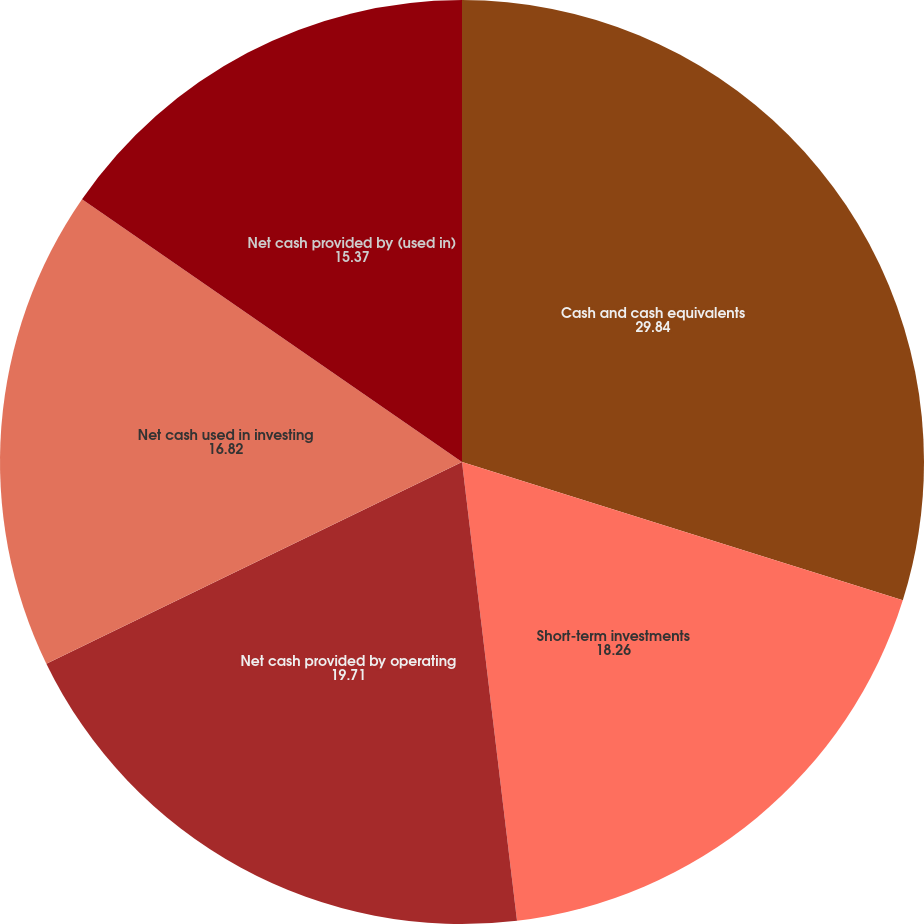<chart> <loc_0><loc_0><loc_500><loc_500><pie_chart><fcel>Cash and cash equivalents<fcel>Short-term investments<fcel>Net cash provided by operating<fcel>Net cash used in investing<fcel>Net cash provided by (used in)<nl><fcel>29.84%<fcel>18.26%<fcel>19.71%<fcel>16.82%<fcel>15.37%<nl></chart> 